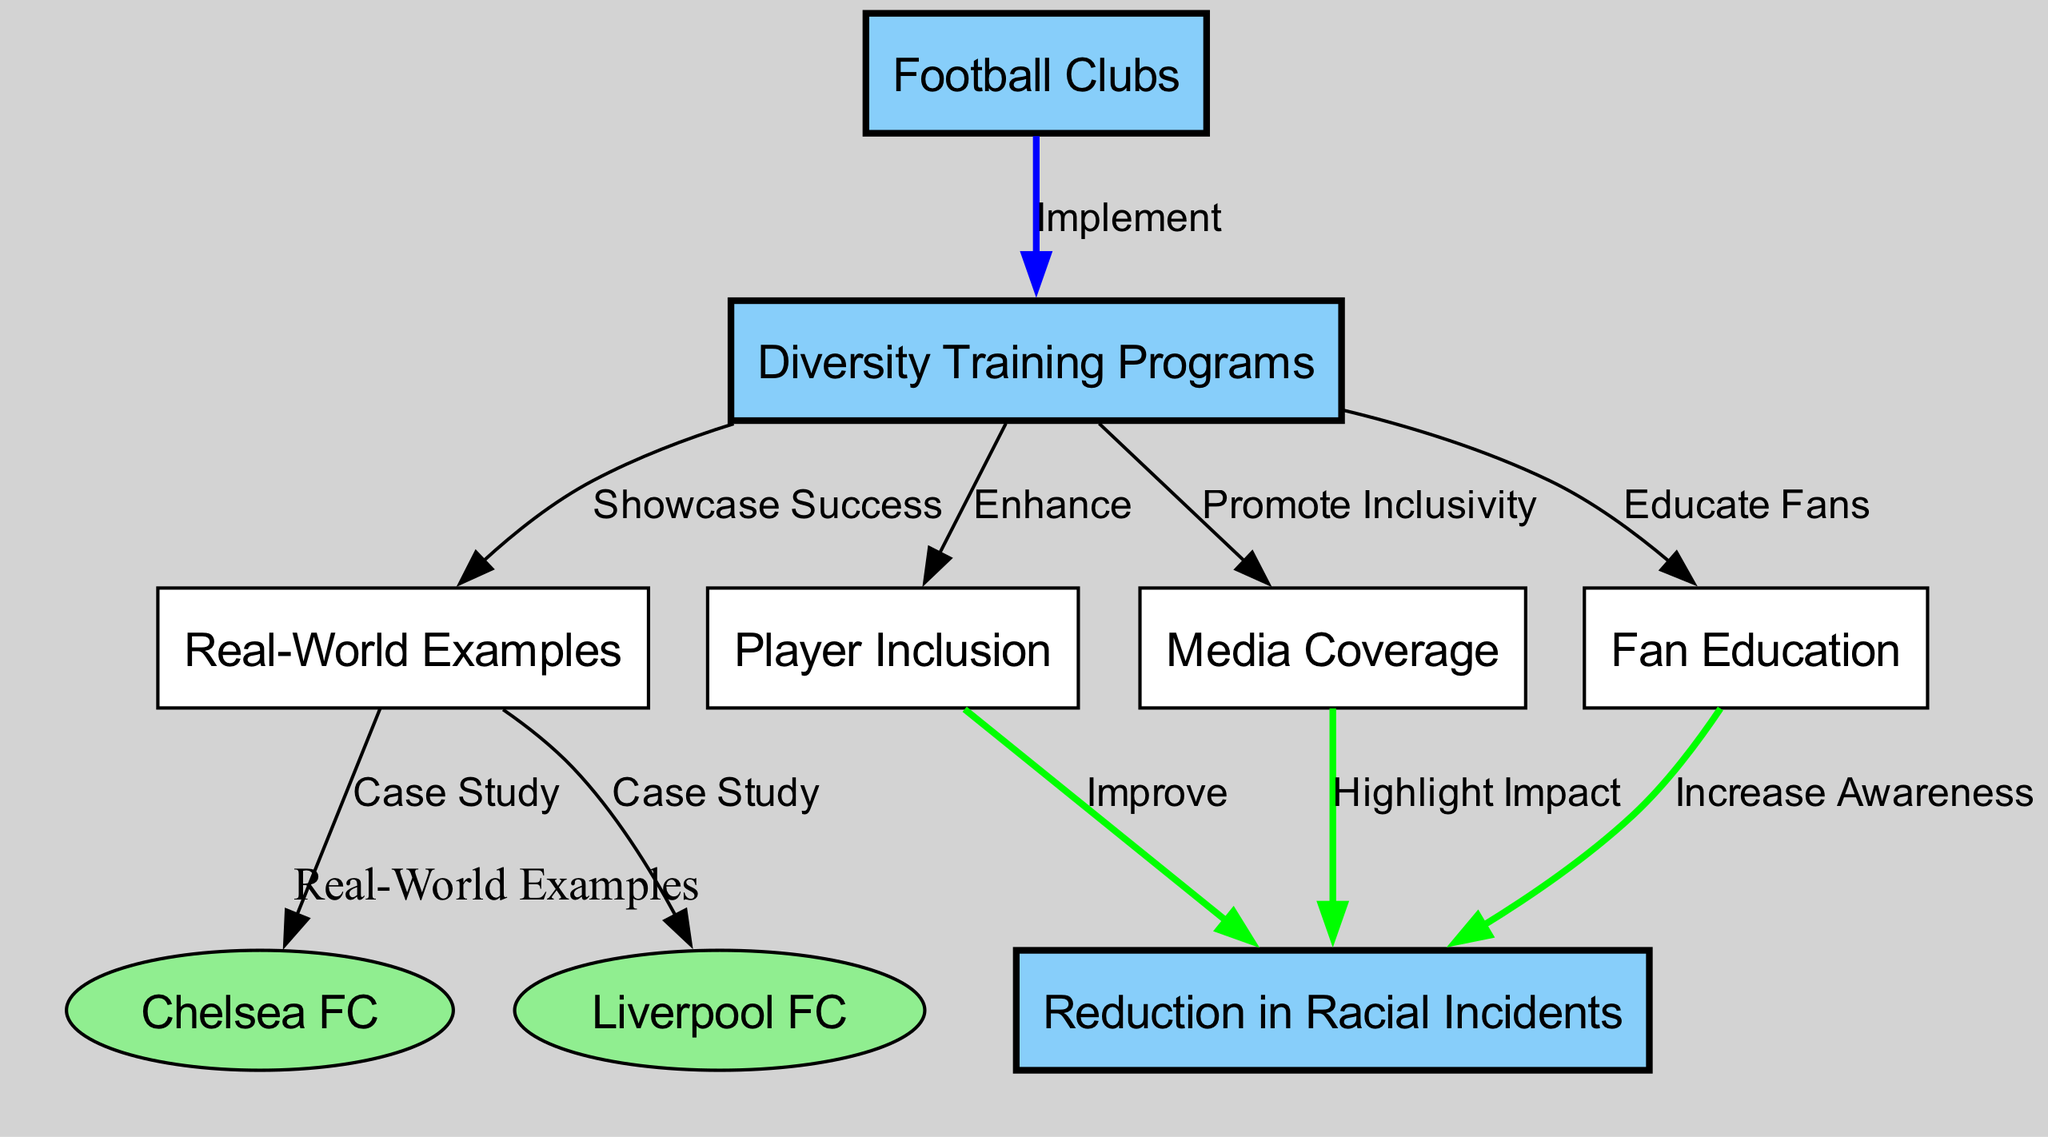What is the main function of the "Diversity Training Programs" node? The "Diversity Training Programs" node signifies that football clubs implement these programs to address diversity issues. It is a central node, directly connected to "Football Clubs," indicating its purpose in fostering inclusivity.
Answer: Implement How many clubs are used as real-world examples in the diagram? The diagram features two clubs as real-world examples: Chelsea FC and Liverpool FC. These are specified in the connections branching from the "Real-World Examples" node.
Answer: 2 What do "Player Inclusion," "Media Coverage," and "Fan Education" have in common regarding their connection to "Diversity Training Programs"? All three nodes are outcomes enhanced by the implementation of "Diversity Training Programs," showing that these programs aim to improve inclusion, representation in media, and educate fans on diversity issues.
Answer: Enhance How does "Player Inclusion" contribute to reducing racial incidents? "Player Inclusion" is shown to improve the reduction of racial incidents in the diagram, indicating that when players from diverse backgrounds are included, the environment becomes less discriminatory, leading to fewer incidents.
Answer: Improve What effect does "Media Coverage" have on racial incidents? The "Media Coverage" node highlights its impact on reducing racial incidents, demonstrating that increased visibility and positive representation in media can influence public perception and behavior, thereby decreasing incidents.
Answer: Highlight Impact What node is linked with a direct outcome of reducing racial incidents but focuses on educating the supporters? The "Fan Education" node is specifically designed to increase awareness among fans, directly connecting its influence to a reduction in racial incidents through informed support and behavior.
Answer: Increase Awareness Which two clubs are specifically mentioned as case studies in the diagram? The clubs highlighted as case studies in the visual representation of the diagram are Chelsea FC and Liverpool FC, showcasing their respective implementations of diversity training.
Answer: Chelsea FC, Liverpool FC What is the overall goal of connecting all nodes through this diagram? The overall goal depicted in the diagram is to showcase the interconnectedness of diversity training and its beneficial outcomes in addressing and reducing racial incidents in football clubs, ultimately creating a more inclusive environment.
Answer: Reduce racial incidents 